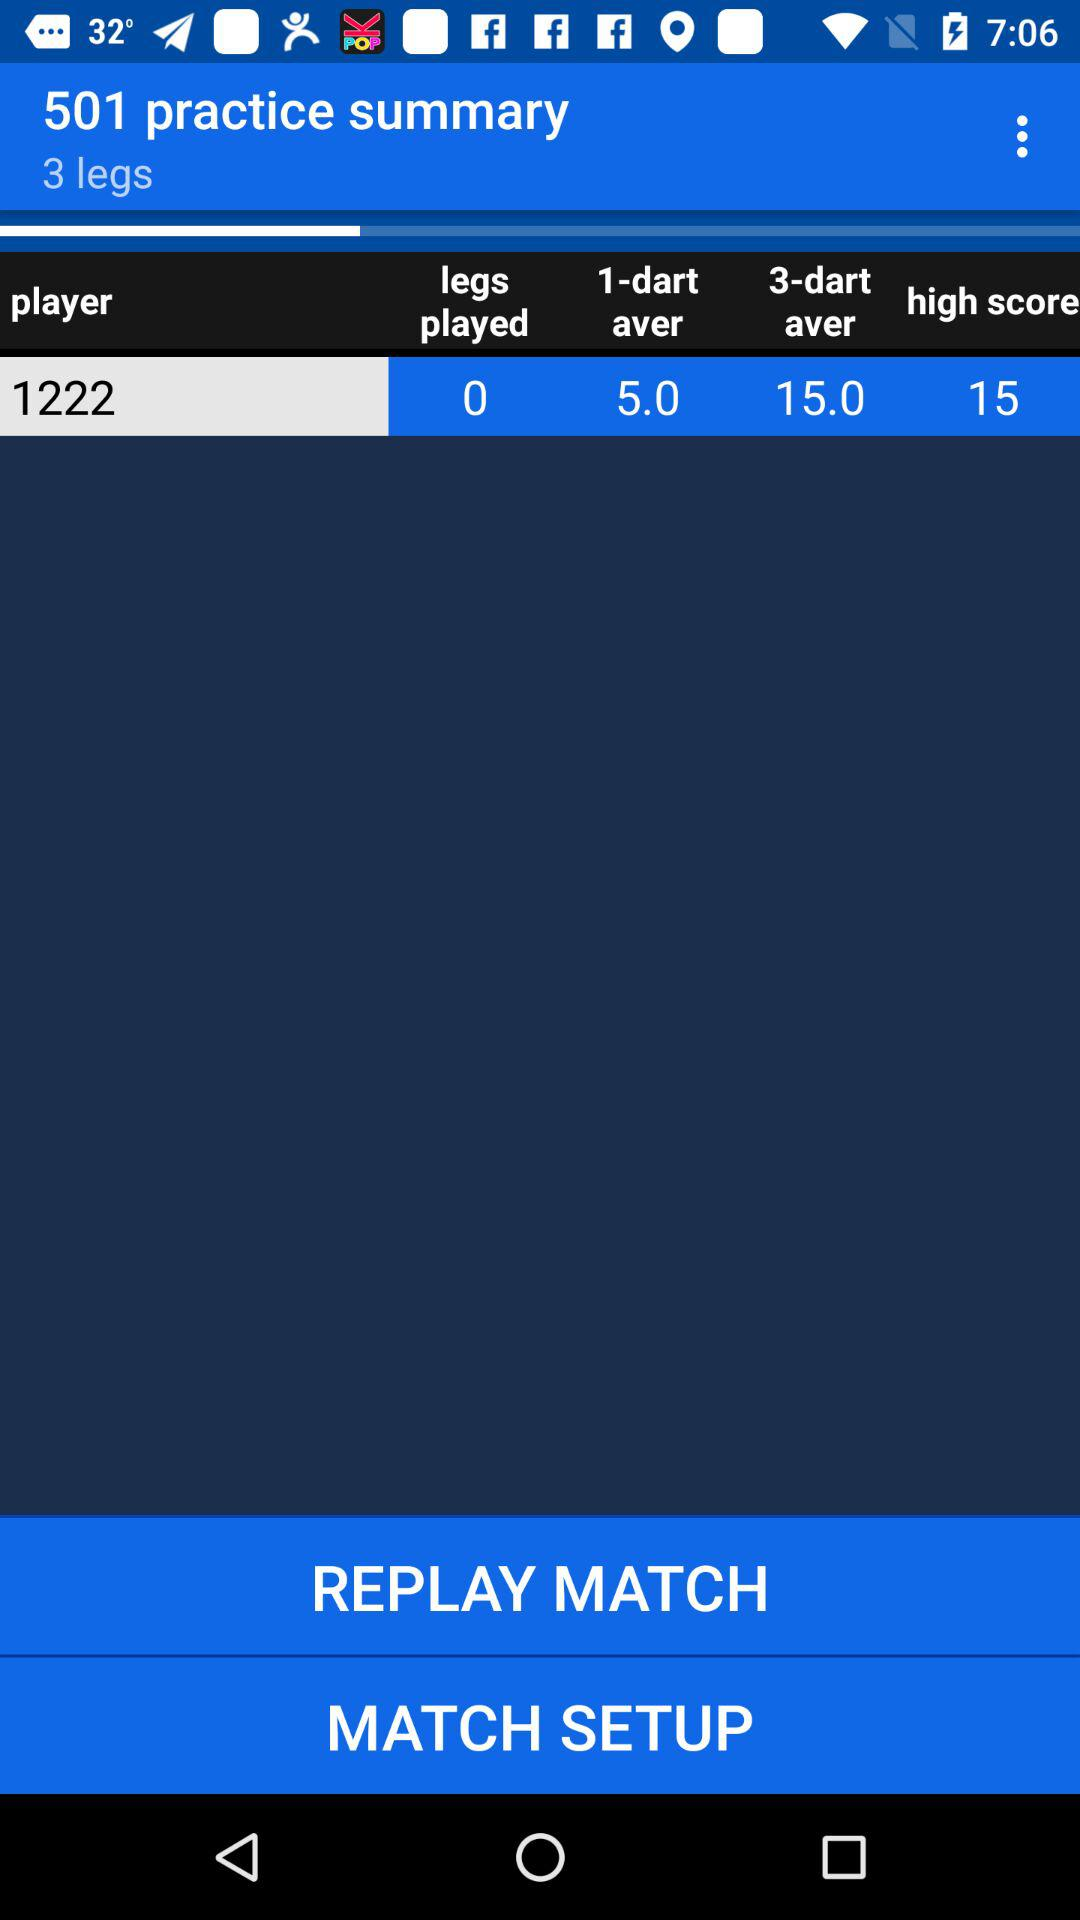How many players are shown here? There are 1222 players. 